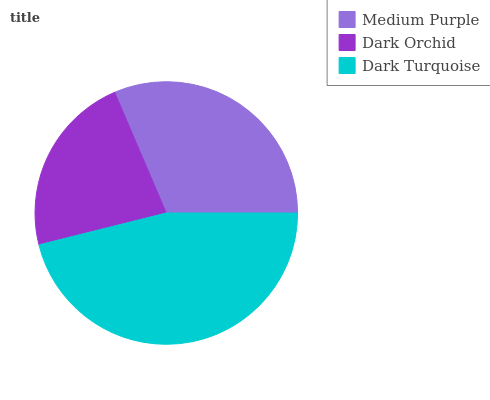Is Dark Orchid the minimum?
Answer yes or no. Yes. Is Dark Turquoise the maximum?
Answer yes or no. Yes. Is Dark Turquoise the minimum?
Answer yes or no. No. Is Dark Orchid the maximum?
Answer yes or no. No. Is Dark Turquoise greater than Dark Orchid?
Answer yes or no. Yes. Is Dark Orchid less than Dark Turquoise?
Answer yes or no. Yes. Is Dark Orchid greater than Dark Turquoise?
Answer yes or no. No. Is Dark Turquoise less than Dark Orchid?
Answer yes or no. No. Is Medium Purple the high median?
Answer yes or no. Yes. Is Medium Purple the low median?
Answer yes or no. Yes. Is Dark Turquoise the high median?
Answer yes or no. No. Is Dark Orchid the low median?
Answer yes or no. No. 